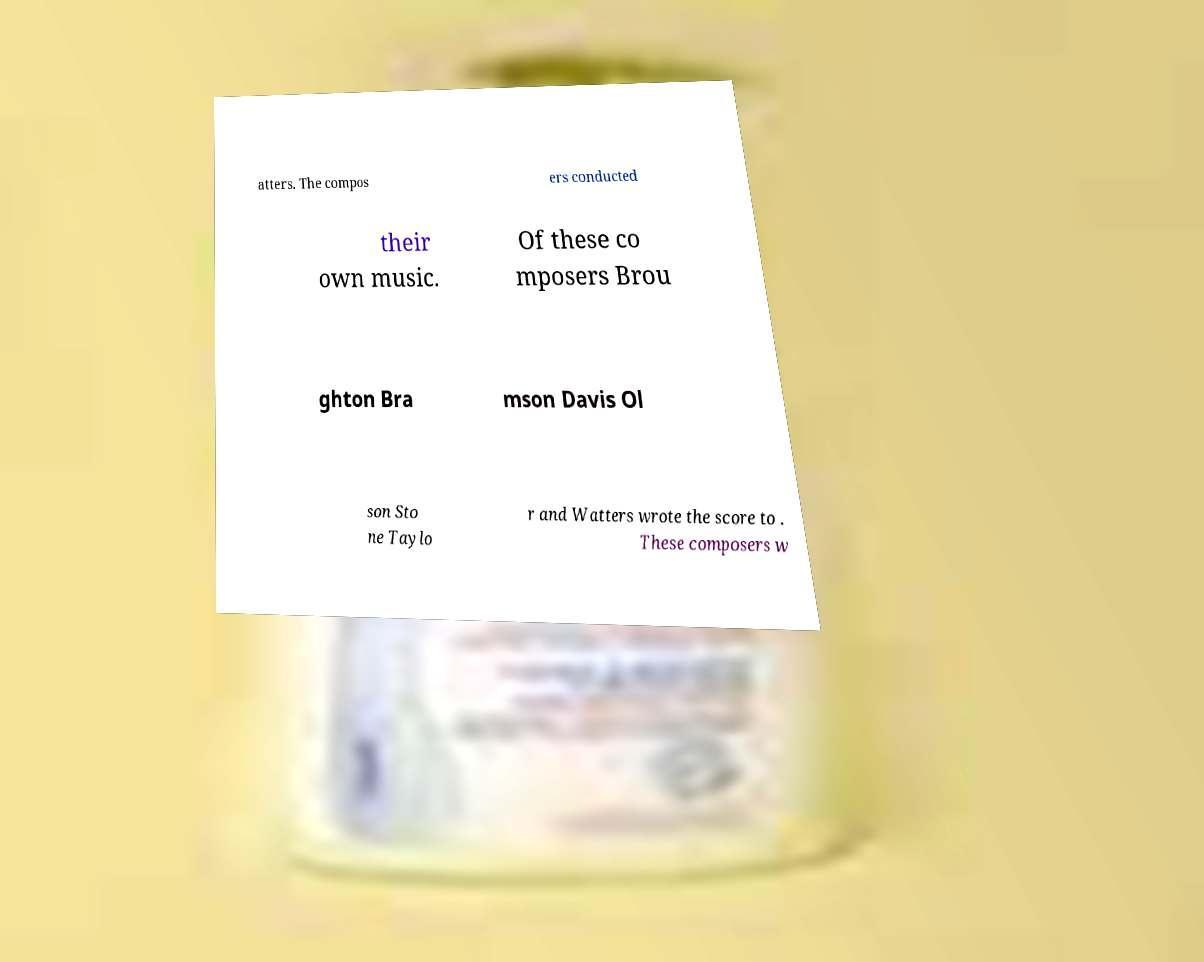What messages or text are displayed in this image? I need them in a readable, typed format. atters. The compos ers conducted their own music. Of these co mposers Brou ghton Bra mson Davis Ol son Sto ne Taylo r and Watters wrote the score to . These composers w 